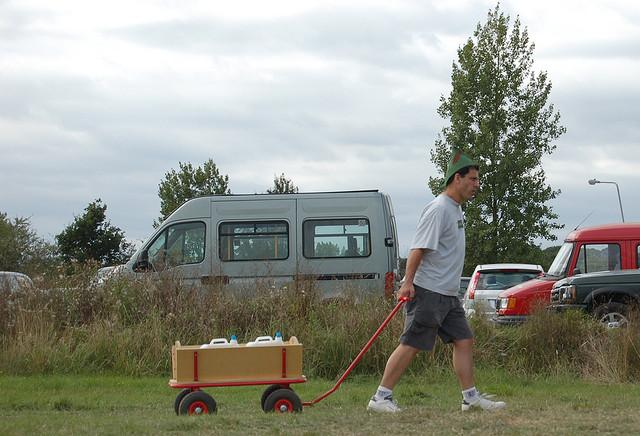What color is the main body of the cart pulled by this guy?

Choices:
A) red
B) orange
C) wood
D) blue wood 